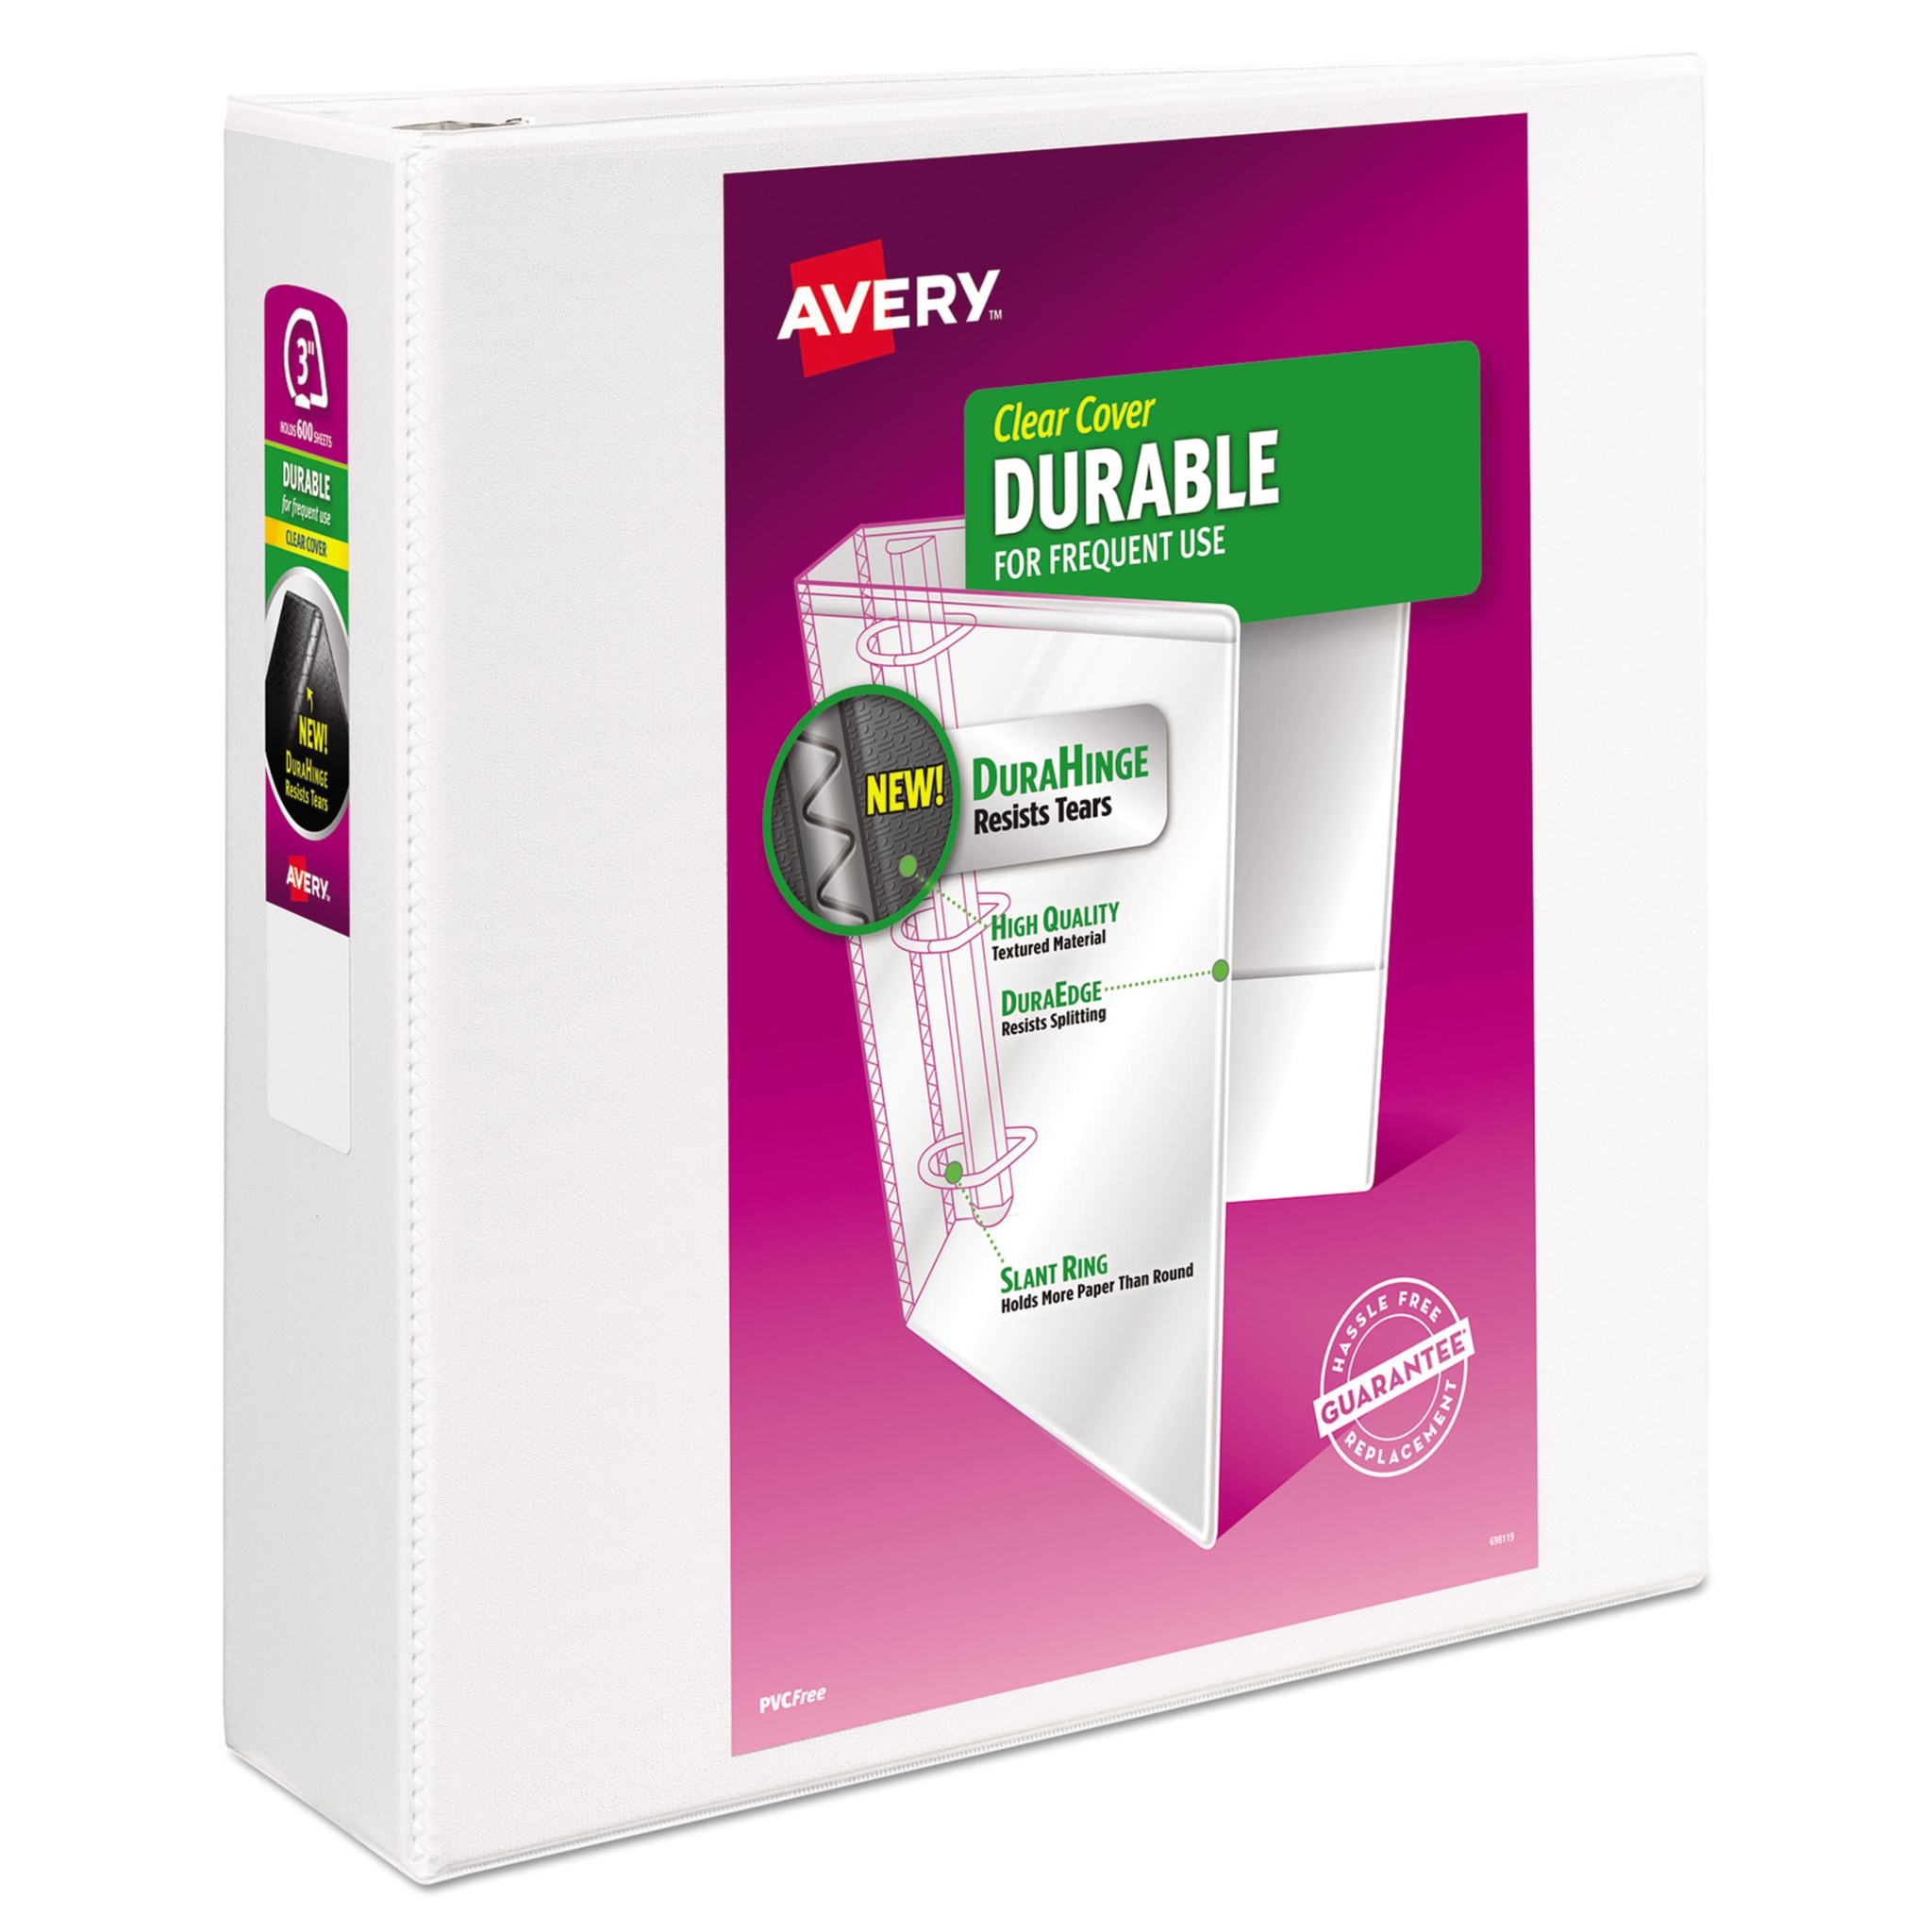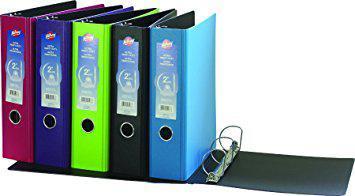The first image is the image on the left, the second image is the image on the right. Examine the images to the left and right. Is the description "The right image contains at least four binders standing vertically." accurate? Answer yes or no. Yes. The first image is the image on the left, the second image is the image on the right. For the images shown, is this caption "The left image contains a single binder, and the right image contains a row of upright binders with circles on the bound edges." true? Answer yes or no. Yes. 